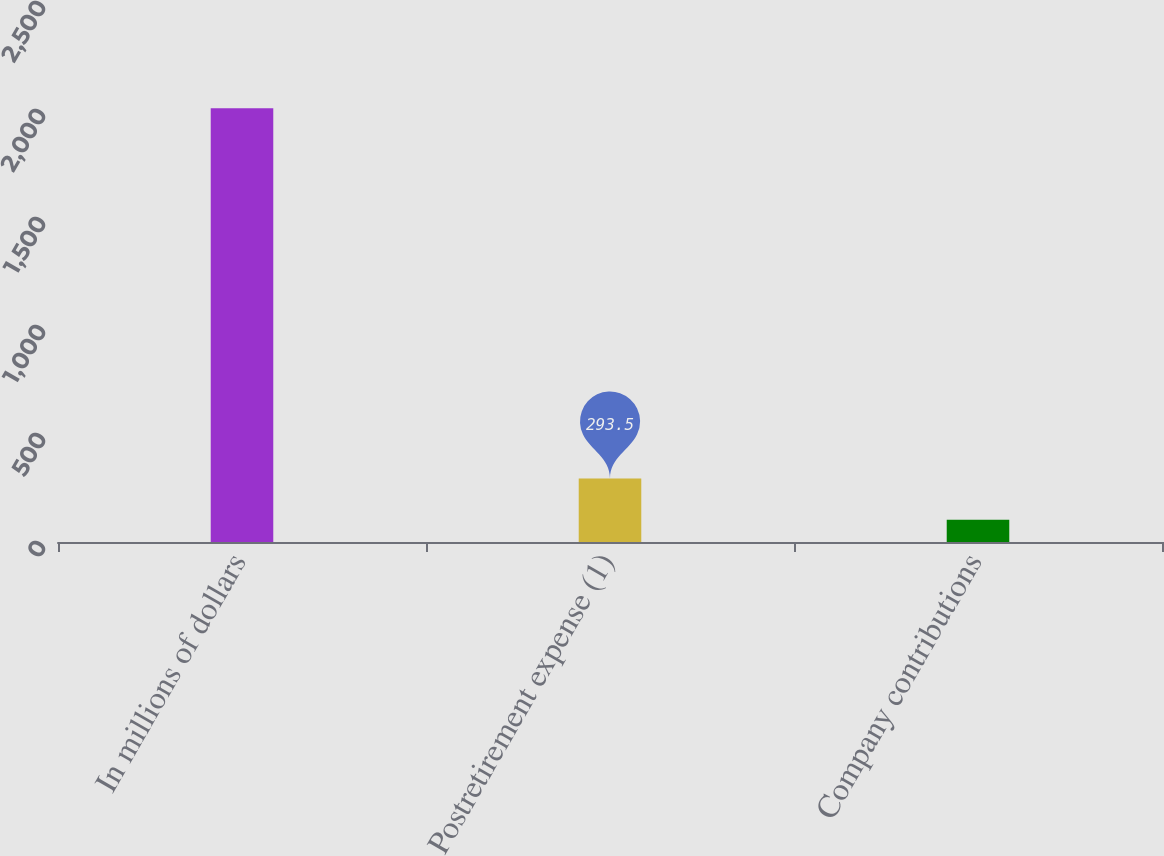Convert chart. <chart><loc_0><loc_0><loc_500><loc_500><bar_chart><fcel>In millions of dollars<fcel>Postretirement expense (1)<fcel>Company contributions<nl><fcel>2008<fcel>293.5<fcel>103<nl></chart> 